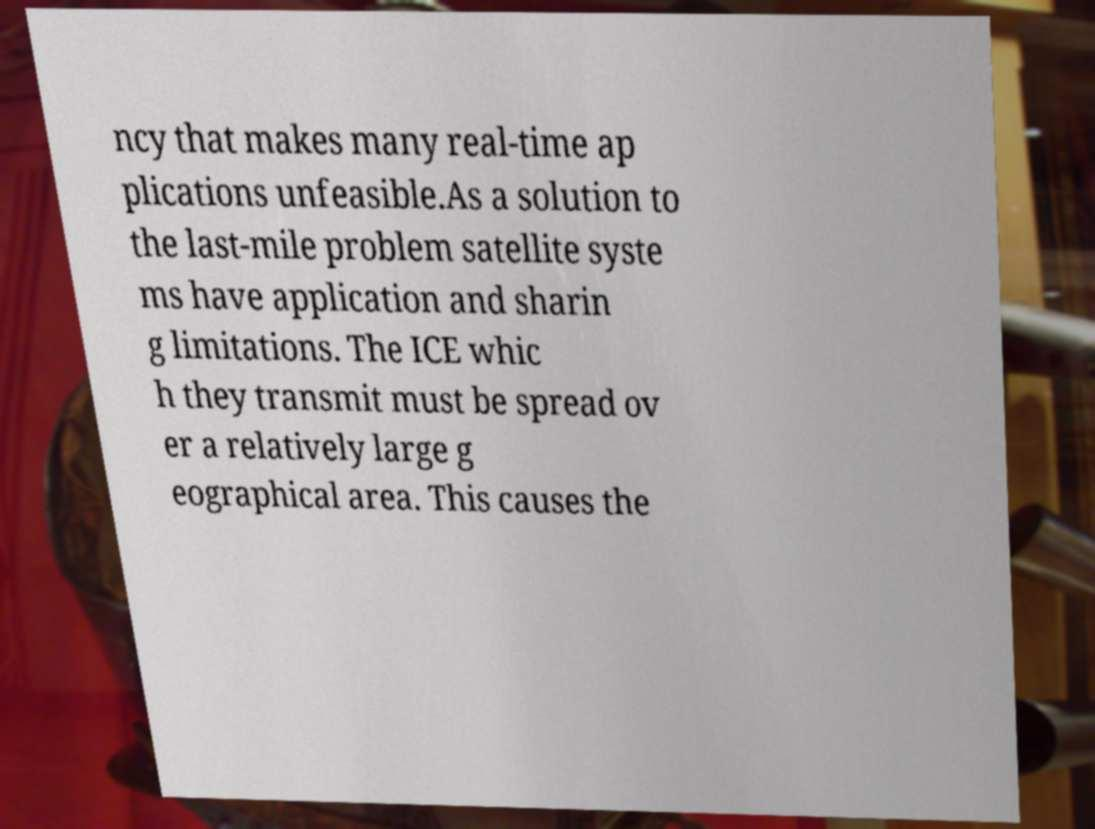What messages or text are displayed in this image? I need them in a readable, typed format. ncy that makes many real-time ap plications unfeasible.As a solution to the last-mile problem satellite syste ms have application and sharin g limitations. The ICE whic h they transmit must be spread ov er a relatively large g eographical area. This causes the 